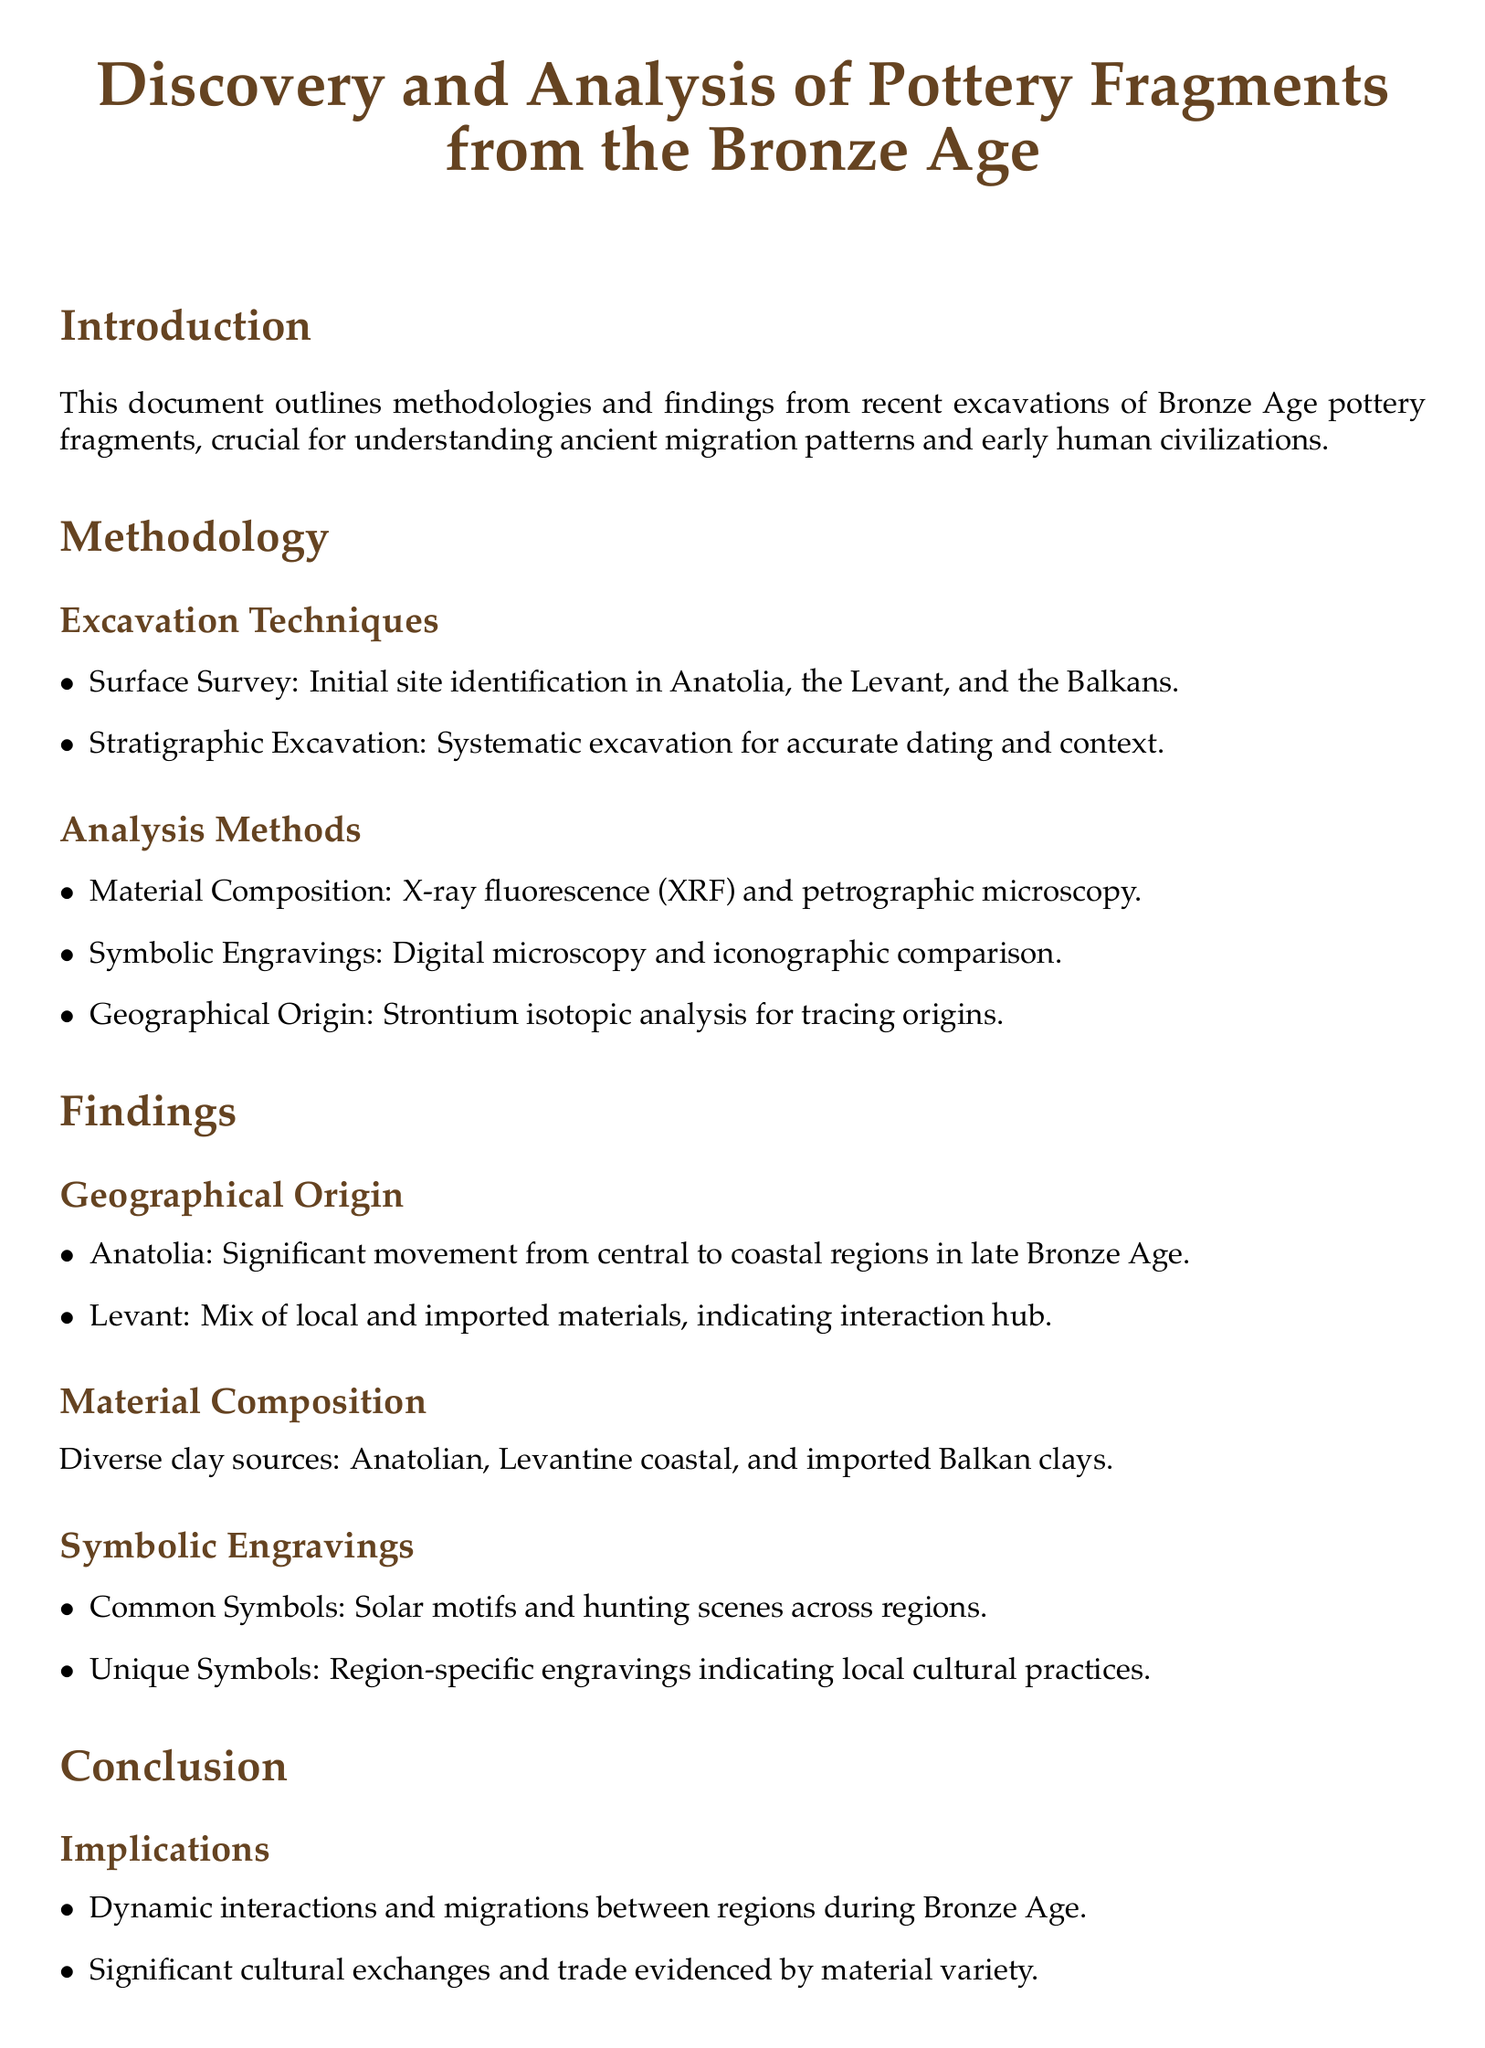What are the excavation techniques used? The document lists surface survey and stratigraphic excavation as the excavation techniques used.
Answer: Surface survey and stratigraphic excavation What analysis method is used for material composition? The document specifies that X-ray fluorescence (XRF) and petrographic microscopy are the analysis methods for material composition.
Answer: X-ray fluorescence (XRF) and petrographic microscopy What significant movement occurred in Anatolia during the late Bronze Age? The document states that there was a significant movement from central to coastal regions in late Bronze Age.
Answer: Central to coastal regions What symbols are commonly found on the pottery fragments? The document mentions solar motifs and hunting scenes as common symbols across regions.
Answer: Solar motifs and hunting scenes In which year was the excavation report from Anatolia published? The document lists the year the excavation report was published, which is 2022.
Answer: 2022 Which regions are identified as interaction hubs in the findings? The findings indicate that the Levant is considered an interaction hub due to the mix of local and imported materials.
Answer: Levant What is the primary implication of the findings? The document concludes that the findings imply dynamic interactions and migrations between regions during the Bronze Age.
Answer: Dynamic interactions and migrations What type of future research is suggested in the document? Future research suggested in the document includes interdisciplinary studies incorporating genetic analysis and broader geographic surveys.
Answer: Interdisciplinary studies Which cultural practices do unique symbols on the pottery fragments indicate? The document states that unique symbols indicate local cultural practices, highlighting regional differences.
Answer: Local cultural practices 